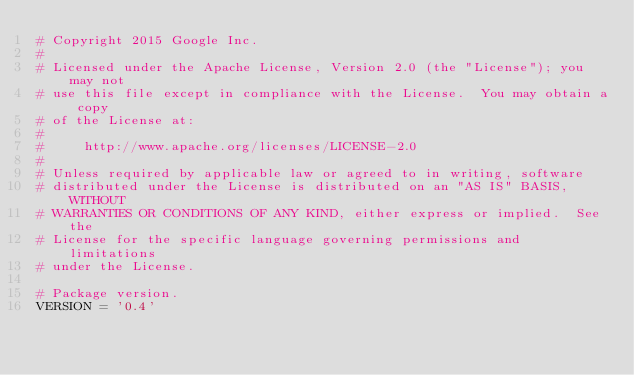Convert code to text. <code><loc_0><loc_0><loc_500><loc_500><_Python_># Copyright 2015 Google Inc.
#
# Licensed under the Apache License, Version 2.0 (the "License"); you may not
# use this file except in compliance with the License.  You may obtain a copy
# of the License at:
#
#     http://www.apache.org/licenses/LICENSE-2.0
#
# Unless required by applicable law or agreed to in writing, software
# distributed under the License is distributed on an "AS IS" BASIS, WITHOUT
# WARRANTIES OR CONDITIONS OF ANY KIND, either express or implied.  See the
# License for the specific language governing permissions and limitations
# under the License.

# Package version.
VERSION = '0.4'
</code> 